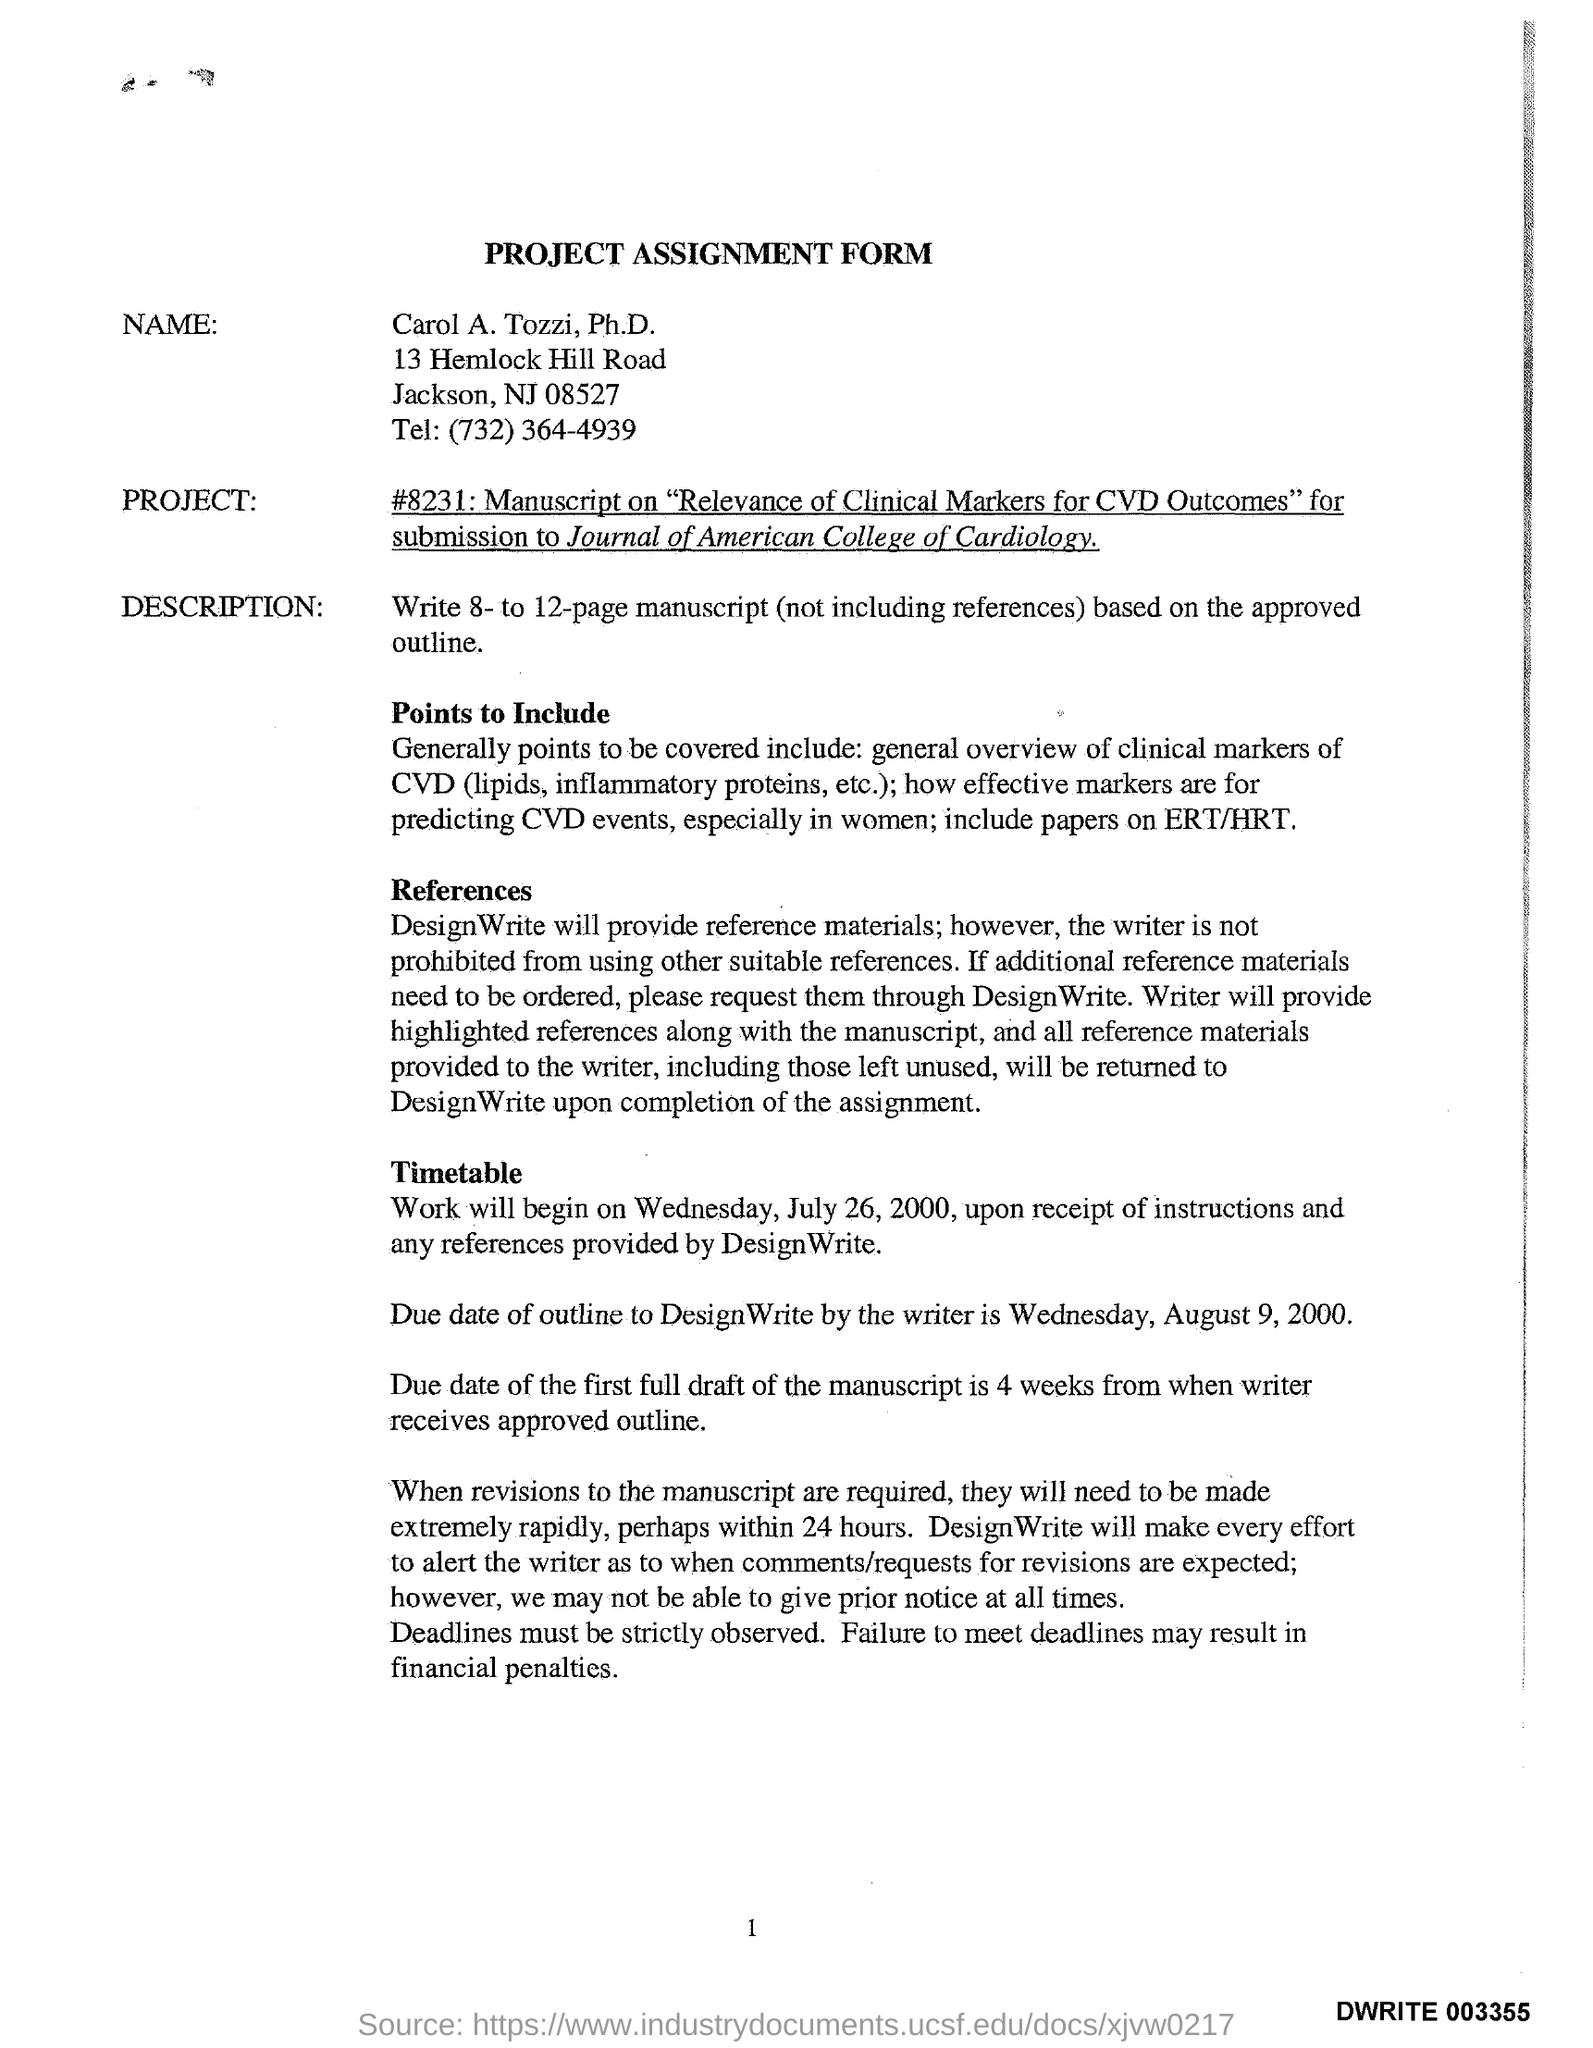Give some essential details in this illustration. The title of the form is the "Form Assignment Project" form. The work will commence on Wednesday, July 26, 2000. 